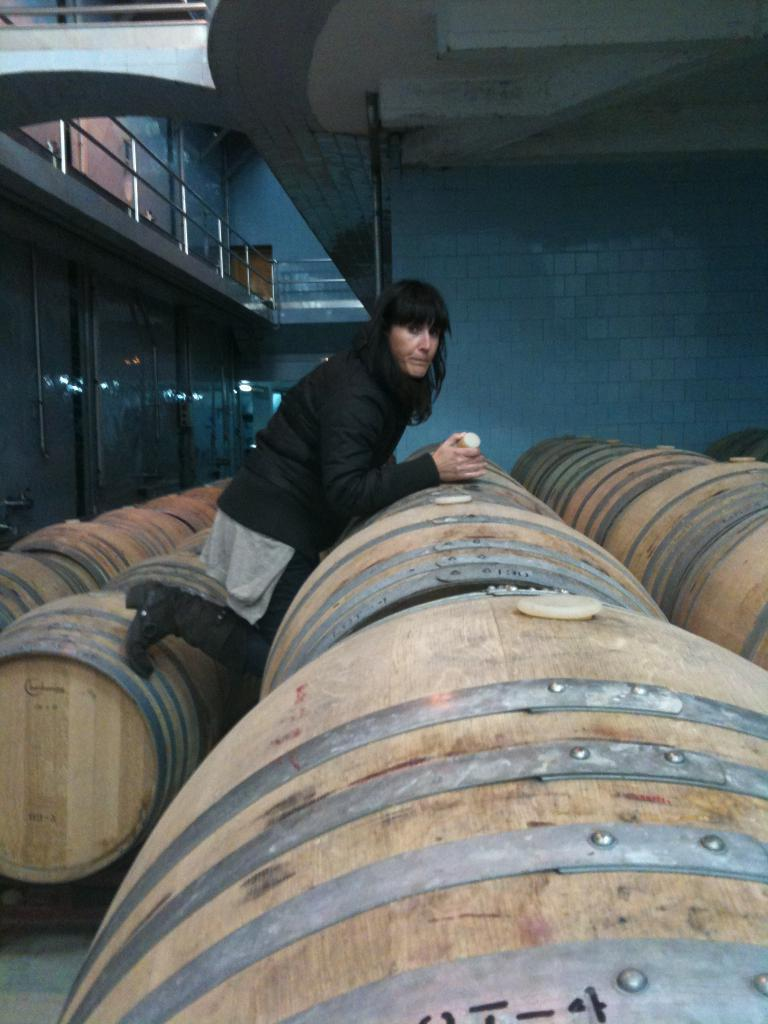Who is the main subject in the image? There is a lady in the image. What is the lady wearing? The lady is wearing a black dress. What is the lady positioned between in the image? The lady is positioned between drum-like objects. What type of pancake is the lady flipping in the image? There is no pancake present in the image, and the lady is not shown flipping anything. 